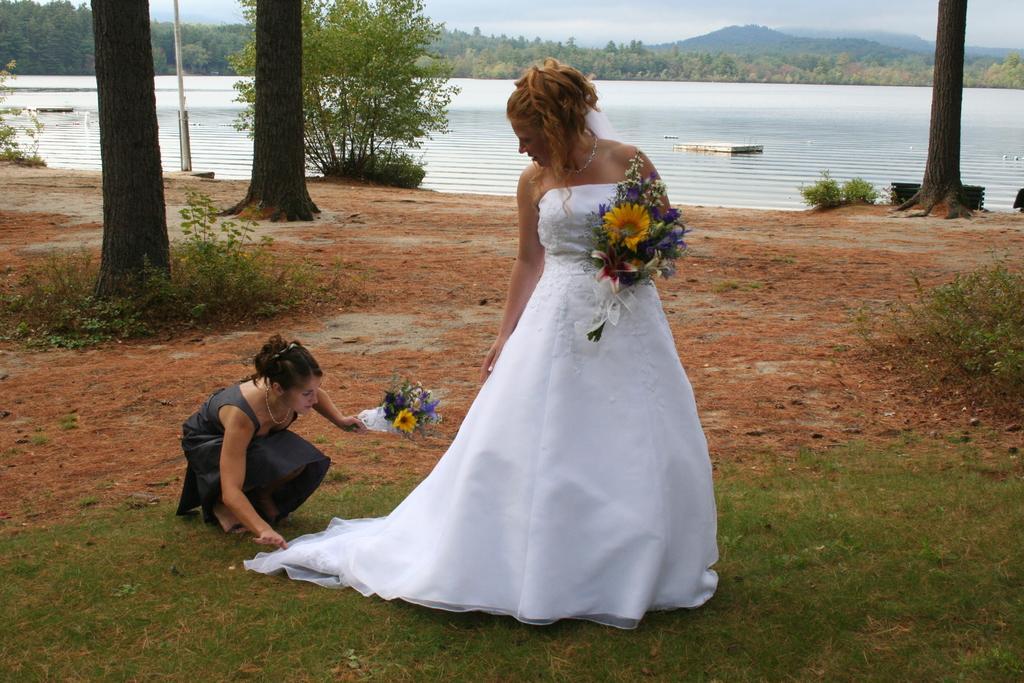Can you describe this image briefly? In this image I can see a woman wearing white dress is standing and holding a flower bouquet in her hand and another woman wearing black dress is holding a flower bouquet in her hand. In the background I can see the ground, few trees, the water, few mountains and the sky. 